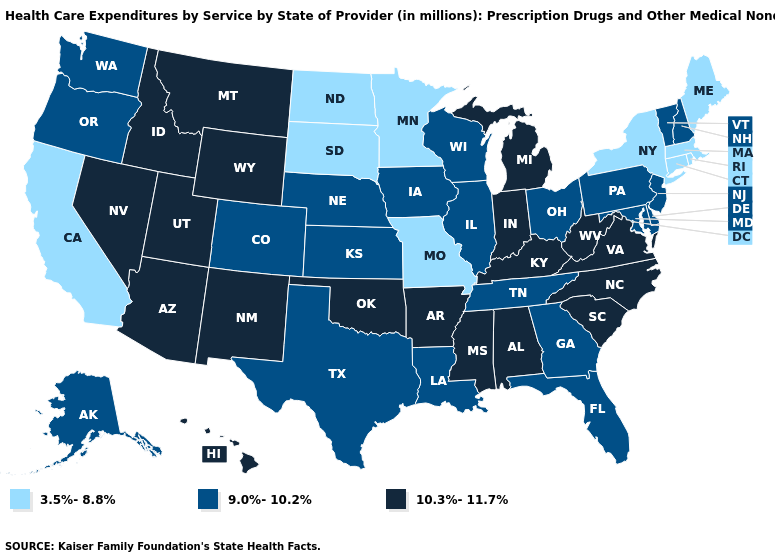What is the value of West Virginia?
Answer briefly. 10.3%-11.7%. What is the highest value in states that border South Carolina?
Give a very brief answer. 10.3%-11.7%. Does Wyoming have the same value as Kansas?
Be succinct. No. How many symbols are there in the legend?
Answer briefly. 3. What is the value of California?
Concise answer only. 3.5%-8.8%. What is the value of Tennessee?
Concise answer only. 9.0%-10.2%. What is the highest value in states that border New Jersey?
Answer briefly. 9.0%-10.2%. What is the lowest value in the USA?
Write a very short answer. 3.5%-8.8%. Which states have the highest value in the USA?
Write a very short answer. Alabama, Arizona, Arkansas, Hawaii, Idaho, Indiana, Kentucky, Michigan, Mississippi, Montana, Nevada, New Mexico, North Carolina, Oklahoma, South Carolina, Utah, Virginia, West Virginia, Wyoming. What is the lowest value in the USA?
Quick response, please. 3.5%-8.8%. How many symbols are there in the legend?
Keep it brief. 3. Name the states that have a value in the range 9.0%-10.2%?
Concise answer only. Alaska, Colorado, Delaware, Florida, Georgia, Illinois, Iowa, Kansas, Louisiana, Maryland, Nebraska, New Hampshire, New Jersey, Ohio, Oregon, Pennsylvania, Tennessee, Texas, Vermont, Washington, Wisconsin. What is the lowest value in the USA?
Answer briefly. 3.5%-8.8%. What is the value of Alaska?
Answer briefly. 9.0%-10.2%. Which states have the lowest value in the USA?
Answer briefly. California, Connecticut, Maine, Massachusetts, Minnesota, Missouri, New York, North Dakota, Rhode Island, South Dakota. 